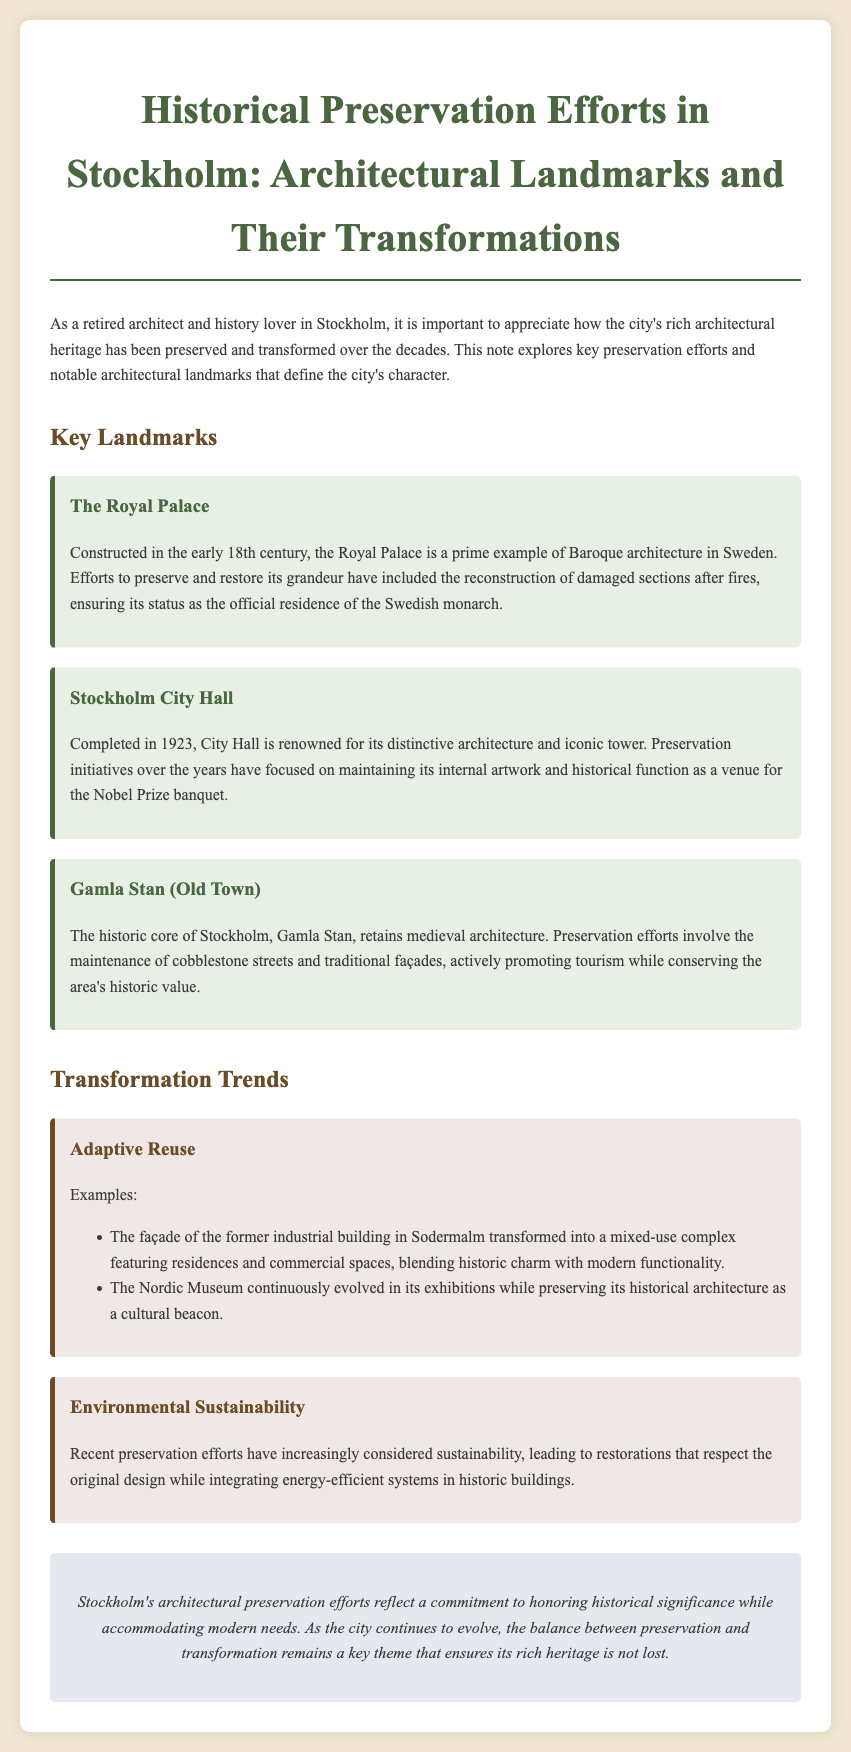What century was the Royal Palace constructed? The Royal Palace was constructed in the early 18th century.
Answer: 18th century What is the main architectural style of the Stockholm City Hall? The Stockholm City Hall is renowned for its distinctive architecture, primarily reflecting a unique style rather than solely one style.
Answer: Unique architecture In what year was the Stockholm City Hall completed? The document states that the City Hall was completed in 1923.
Answer: 1923 Which area retains medieval architecture? The document mentions Gamla Stan as the area that retains medieval architecture.
Answer: Gamla Stan What trend involves the preservation of historic buildings with modern functionalities? The document describes the adaptive reuse of buildings as a trend that involves preservation with modern functionalities.
Answer: Adaptive Reuse How has preservation considered modern environmental practices recently? The document indicates that recent preservation efforts have increasingly considered sustainability and energy-efficient systems.
Answer: Sustainability What is one notable characteristic of Gamla Stan? The historic core of Stockholm, Gamla Stan, is noted for its cobblestone streets and traditional façades.
Answer: Cobblestone streets What significant event takes place at the Stockholm City Hall? The document notes that the Stockholm City Hall functions as a venue for the Nobel Prize banquet.
Answer: Nobel Prize banquet 